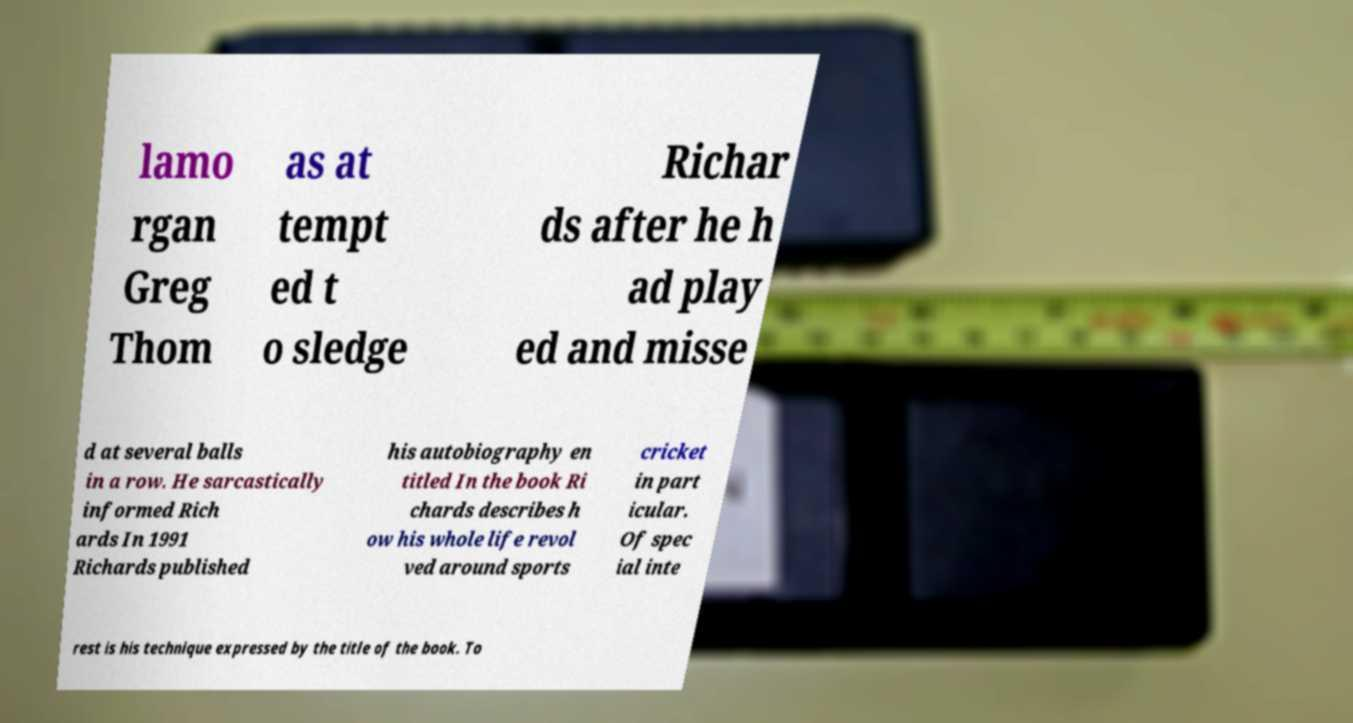Can you accurately transcribe the text from the provided image for me? lamo rgan Greg Thom as at tempt ed t o sledge Richar ds after he h ad play ed and misse d at several balls in a row. He sarcastically informed Rich ards In 1991 Richards published his autobiography en titled In the book Ri chards describes h ow his whole life revol ved around sports cricket in part icular. Of spec ial inte rest is his technique expressed by the title of the book. To 